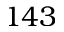Convert formula to latex. <formula><loc_0><loc_0><loc_500><loc_500>1 4 3</formula> 